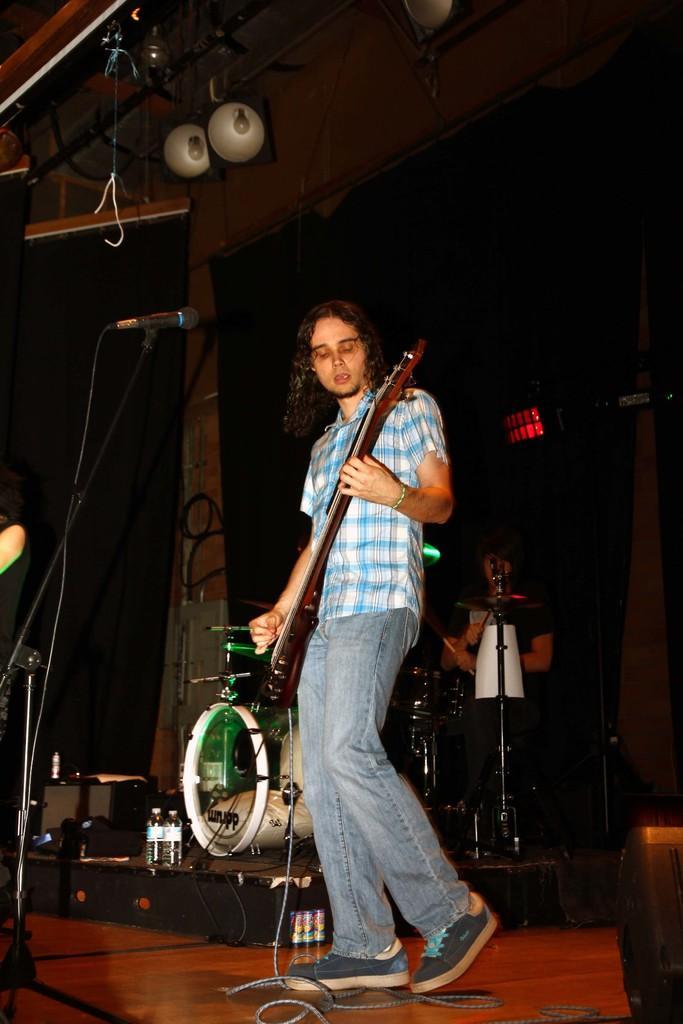Could you give a brief overview of what you see in this image? In this image I can see a person standing in-front of the mic and holding the guitar. In the background there is a drum set. 